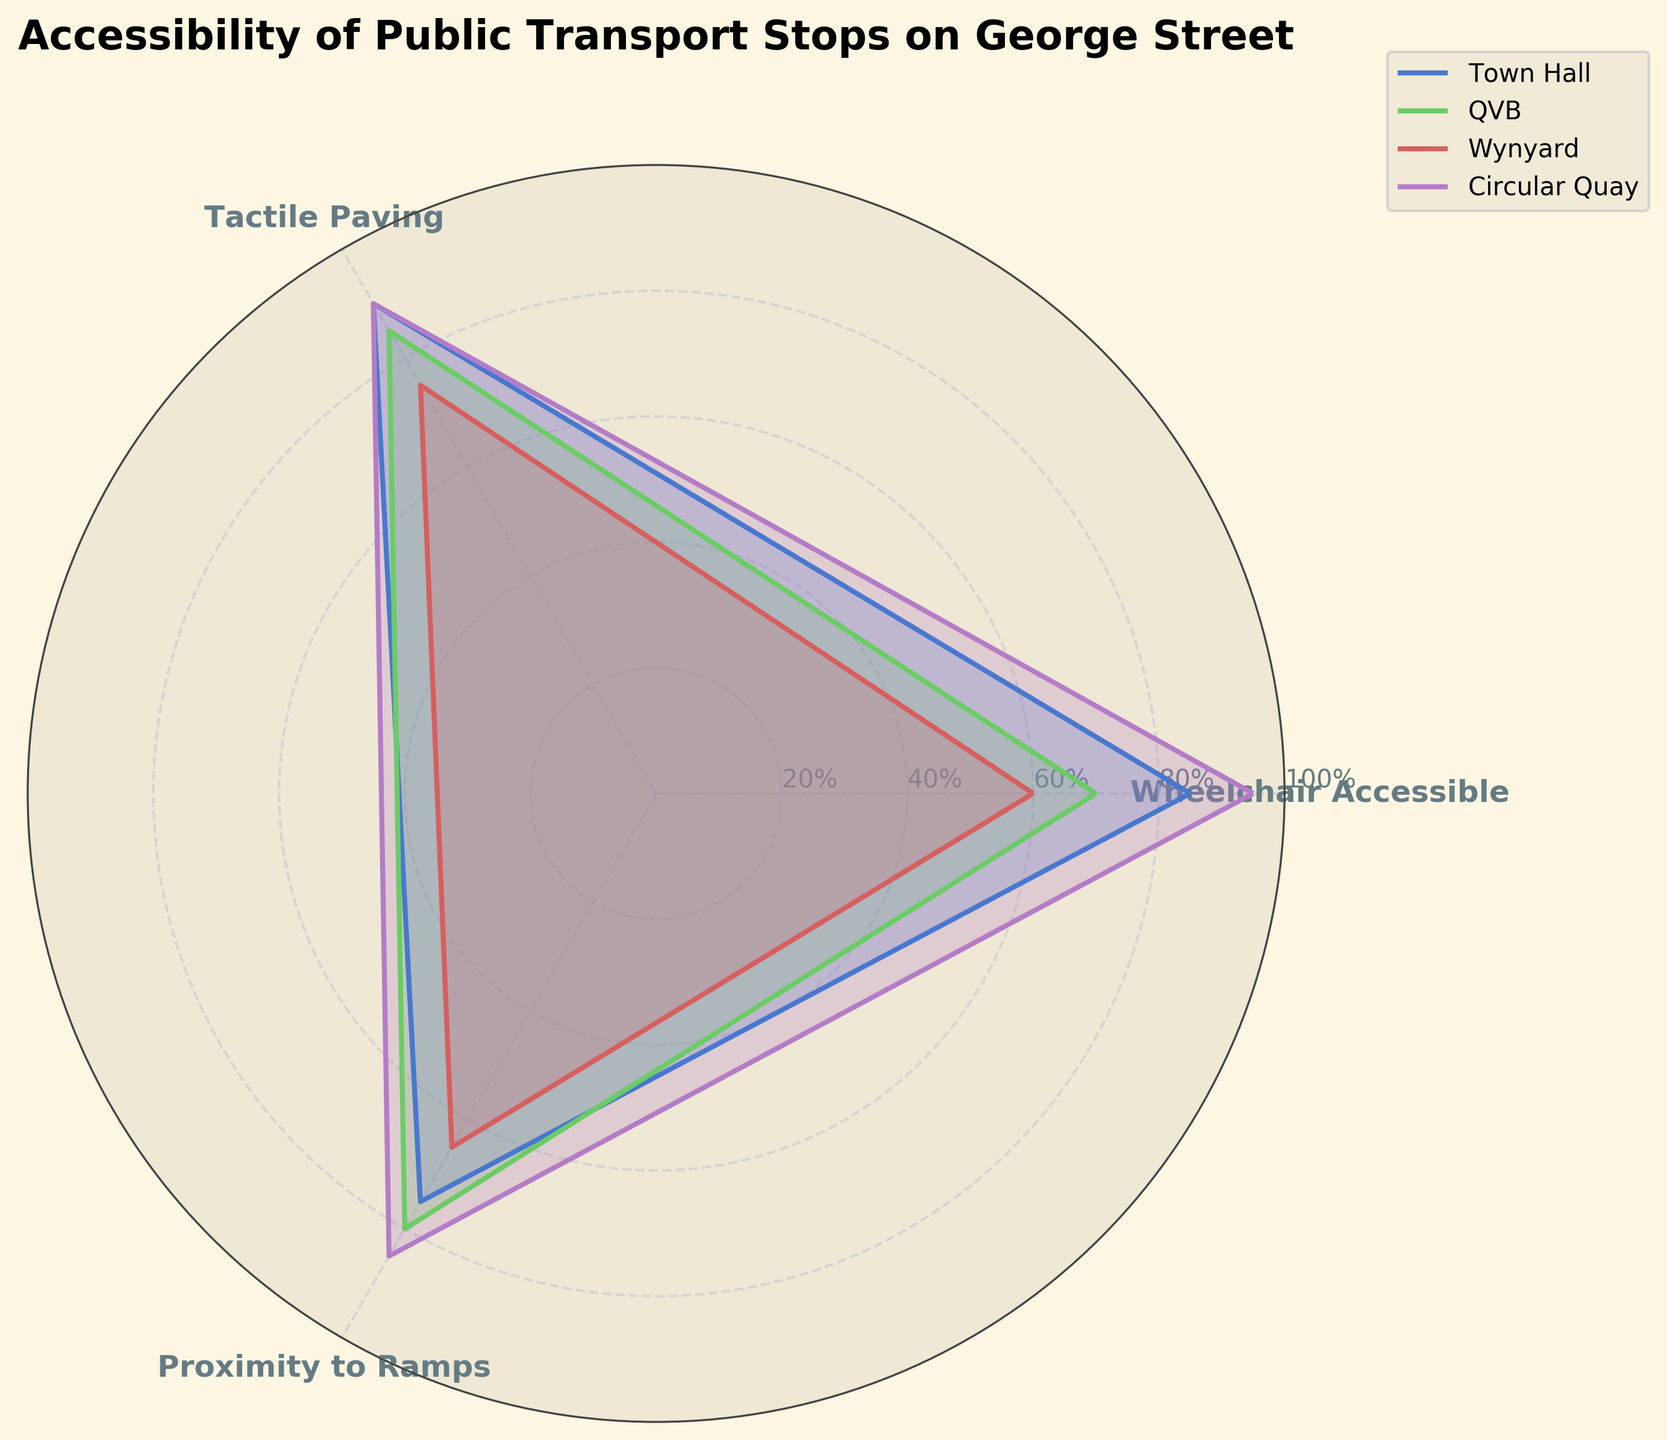What is the title of the figure? The title of the figure is shown at the top of the chart. It reads "Accessibility of Public Transport Stops on George Street".
Answer: Accessibility of Public Transport Stops on George Street Which public transport stop has the highest wheelchair accessibility rating? By looking at the figure, we can see that the line representing "Circular Quay" extends furthest in the direction labeled "Wheelchair Accessible". This indicates it has the highest value in this category.
Answer: Circular Quay Are there any stops with the same tactile paving rating? By examining the figure, we can observe that both "Town Hall" and "Circular Quay" have lines extending to the same point in the direction labeled "Tactile Paving", suggesting they have the same rating.
Answer: Town Hall and Circular Quay Which stop has the lowest proximity to ramps rating, and what is the value? Looking at the figure, the line for "Wynyard" in the direction labeled "Proximity to Ramps" is the shortest, indicating the lowest rating. By checking the radial distance, this value appears to be 65.
Answer: Wynyard, 65 What is the average tactile paving rating for all the stops? To calculate the average tactile paving rating, we sum the values for all stops and then divide by the number of stops. The values are 90, 85, 75, and 90. Thus, (90 + 85 + 75 + 90) / 4 = 85.
Answer: 85 Which stop shows the most balanced accessibility among all the categories? A balanced accessibility implies the values for each criterion (Wheelchair Accessible, Tactile Paving, Proximity to Ramps) are relatively close to each other. By visual inspection, "Circular Quay" shows the most balanced values as its lines in all directions are similar in length.
Answer: Circular Quay How does the wheelchair accessibility of Wynyard compare to Town Hall? The figure shows the line for "Wynyard" in the direction labeled "Wheelchair Accessible" is shorter than the line for "Town Hall". Wynyard has a 60 rating, while Town Hall has 85.
Answer: Wynyard is less accessible Which stop has the closest ratings for both wheelchair accessibility and tactile paving? We need to check the figure for the smallest gap between the 'Wheelchair Accessible' and 'Tactile Paving' ratings for each stop. "QVB" has values 70 and 85, Town Hall has 85 and 90, Wynyard has 60 and 75, and Circular Quay has 95 and 90. "Town Hall" has the closest ratings: 85 and 90.
Answer: Town Hall Which stop has a higher tactile paving rating than its proximity to ramps rating by more than 10 units? From the visual data:
- Town Hall: 90 (tactile) and 75 (ramps), difference = 15
- QVB: 85 (tactile) and 80 (ramps), difference = 5
- Wynyard: 75 (tactile) and 65 (ramps), difference = 10
- Circular Quay: 90 (tactile) and 85 (ramps), difference = 5
Town Hall is the stop with a difference greater than 10 units.
Answer: Town Hall If we were to improve the lowest performing stop in each category, what would those improvements be? We need to identify the lowest values in each category from the figure:
- Wheelchair Accessible: 60 (Wynyard)
- Tactile Paving: 75 (Wynyard)
- Proximity to Ramps: 65 (Wynyard)
Improving these would mean targeting Wynyard in all indicated categories.
Answer: Improve Wynyard in all categories 